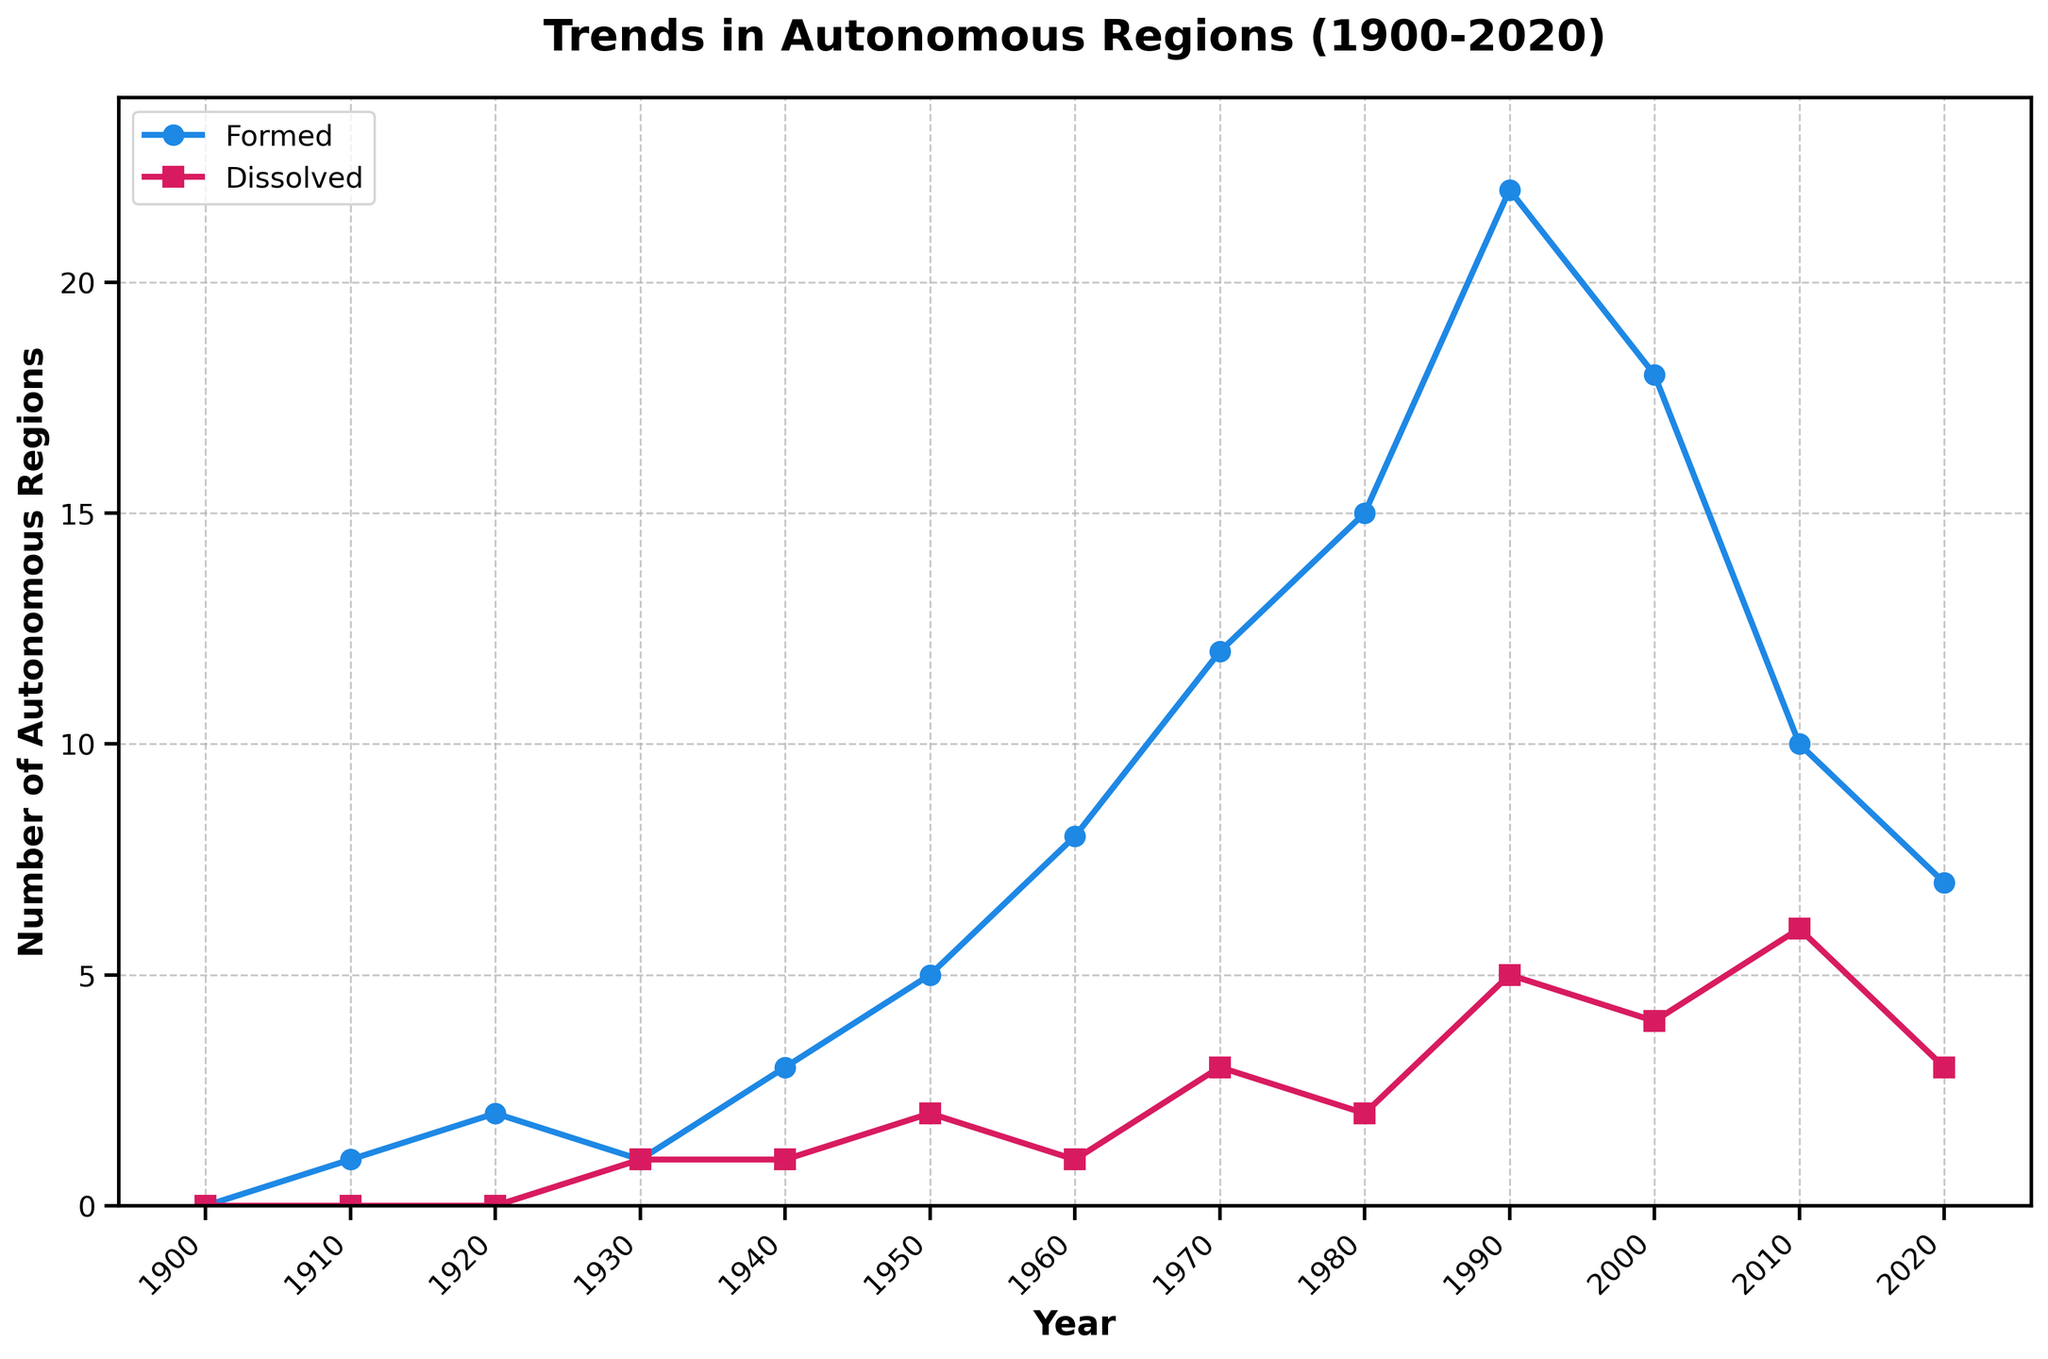What trend can be observed in the formation of autonomous regions from 1900 to 2020? The plot shows an increase in the number of autonomous regions formed from 1900 to 1990, peaking in 1990, followed by a decline after 2000.
Answer: Increase until 1990, then decline In which year did the number of dissolved autonomous regions peak? By observing the plot, the highest point for dissolved autonomous regions is in 2010.
Answer: 2010 What is the difference between the number of autonomous regions formed and dissolved in 1960? In 1960, the number of autonomous regions formed is 8, and dissolved is 1. The difference between them is 8 - 1 = 7.
Answer: 7 How does the number of autonomous regions formed in 1980 compare to those in 2010? The number in 1980 for formed regions is higher. Observing the plot, 1980 has 15 formed regions and 2010 has 10.
Answer: Higher in 1980 What color is used to represent autonomous regions that were formed? In the plot, the color used for the line and markers representing formed autonomous regions is blue.
Answer: Blue Between which consecutive decades was the largest increase in the formation of autonomous regions observed? By looking at the plot, the largest increase is between 1960 and 1970, where the number of formed regions jumps from 8 to 12, an increase of 4.
Answer: Between 1960 and 1970 What is the sum of autonomous regions formed and dissolved in 2000? Referring to the plot, the number of autonomous regions formed in 2000 is 18, and dissolved is 4. The sum of these values is 18 + 4 = 22.
Answer: 22 What is the average number of autonomous regions dissolved from 1940 to 1970? From the plot, the values for dissolved regions in 1940, 1950, 1960, and 1970 are 1, 2, 1, and 3 respectively. Adding these: 1+2+1+3 = 7. There are 4 years, so the average is 7 / 4 = 1.75.
Answer: 1.75 In which decade did autonomous region formation exceed dissolution by the largest margin? Comparing the gaps visually, the largest margin appears between formation and dissolution in 1990 as formation = 22 and dissolution = 5, giving a difference of 22 - 5 = 17.
Answer: 1990 How does the general trend of dissolved autonomous regions from 1900 to 2020 compare with that of formed regions? The trend for dissolved regions shows a lower and more gradual increase compared to the more significant and variable trend of formed regions that peaks and then declines.
Answer: Gradual increase vs. variable with peak and decline 